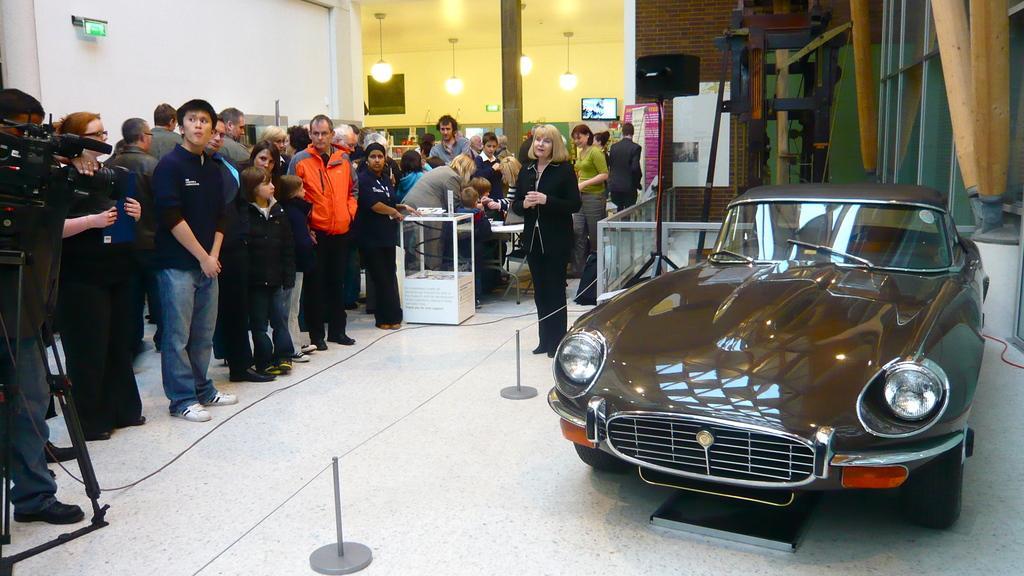Please provide a concise description of this image. In this image we can see a group of people standing. A person is holding a camera at the left side of the image. There is a vehicle in the image. There is a television in the image. There are few objects in the image. There are few lights in the image. There are few barriers beside a car in the image. 